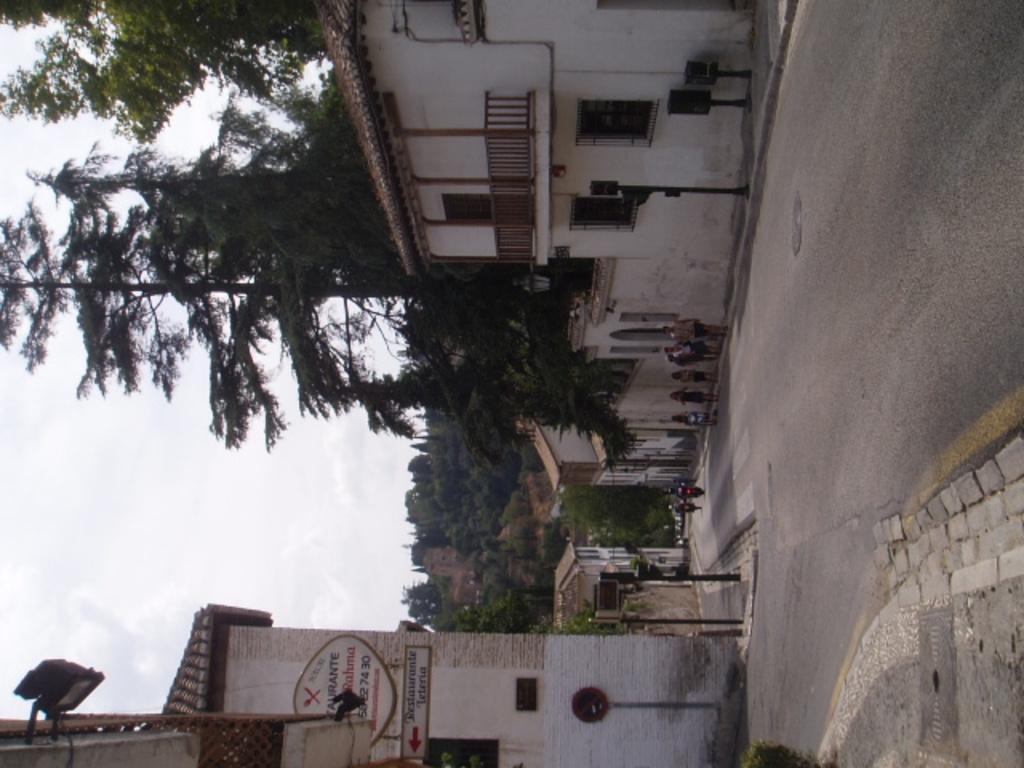Can you describe this image briefly? It is the vertical image in which we can see that there is a road in the middle. On the road there are two bikes. There are buildings on either side of the road. There are few people walking on the footpath. On the right side there are poles on the footpath. There is a hoarding attached to the building. In the background there are trees. On the right side there are few poles on the footpath. 